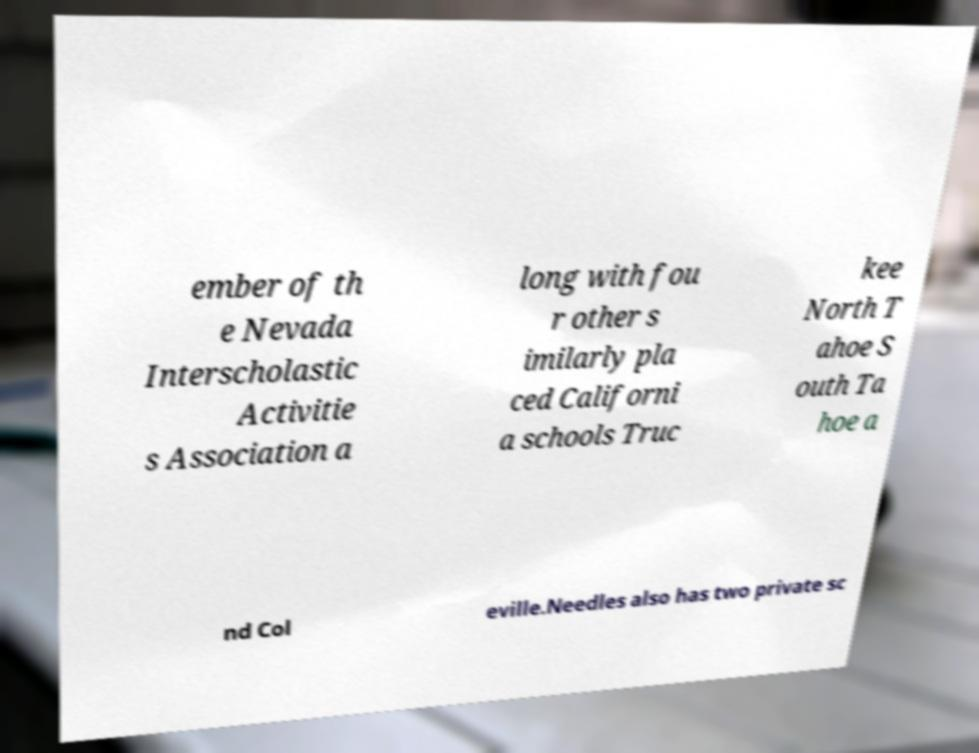Could you assist in decoding the text presented in this image and type it out clearly? ember of th e Nevada Interscholastic Activitie s Association a long with fou r other s imilarly pla ced Californi a schools Truc kee North T ahoe S outh Ta hoe a nd Col eville.Needles also has two private sc 